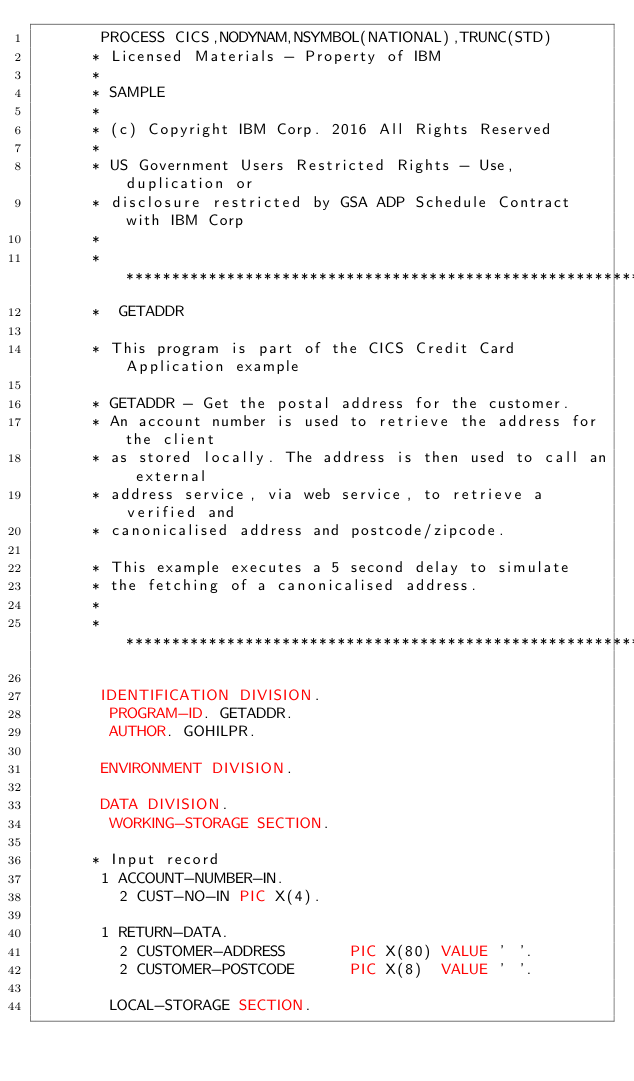Convert code to text. <code><loc_0><loc_0><loc_500><loc_500><_COBOL_>       PROCESS CICS,NODYNAM,NSYMBOL(NATIONAL),TRUNC(STD)
      * Licensed Materials - Property of IBM
      *
      * SAMPLE
      *
      * (c) Copyright IBM Corp. 2016 All Rights Reserved
      *
      * US Government Users Restricted Rights - Use, duplication or
      * disclosure restricted by GSA ADP Schedule Contract with IBM Corp
      *
      ******************************************************************
      *  GETADDR

      * This program is part of the CICS Credit Card Application example

      * GETADDR - Get the postal address for the customer.
      * An account number is used to retrieve the address for the client
      * as stored locally. The address is then used to call an external
      * address service, via web service, to retrieve a verified and
      * canonicalised address and postcode/zipcode.

      * This example executes a 5 second delay to simulate
      * the fetching of a canonicalised address.
      *
      ******************************************************************

       IDENTIFICATION DIVISION.
        PROGRAM-ID. GETADDR.
        AUTHOR. GOHILPR.

       ENVIRONMENT DIVISION.

       DATA DIVISION.
        WORKING-STORAGE SECTION.

      * Input record
       1 ACCOUNT-NUMBER-IN.
         2 CUST-NO-IN PIC X(4).

       1 RETURN-DATA.
         2 CUSTOMER-ADDRESS       PIC X(80) VALUE ' '.
         2 CUSTOMER-POSTCODE      PIC X(8)  VALUE ' '.

        LOCAL-STORAGE SECTION.</code> 